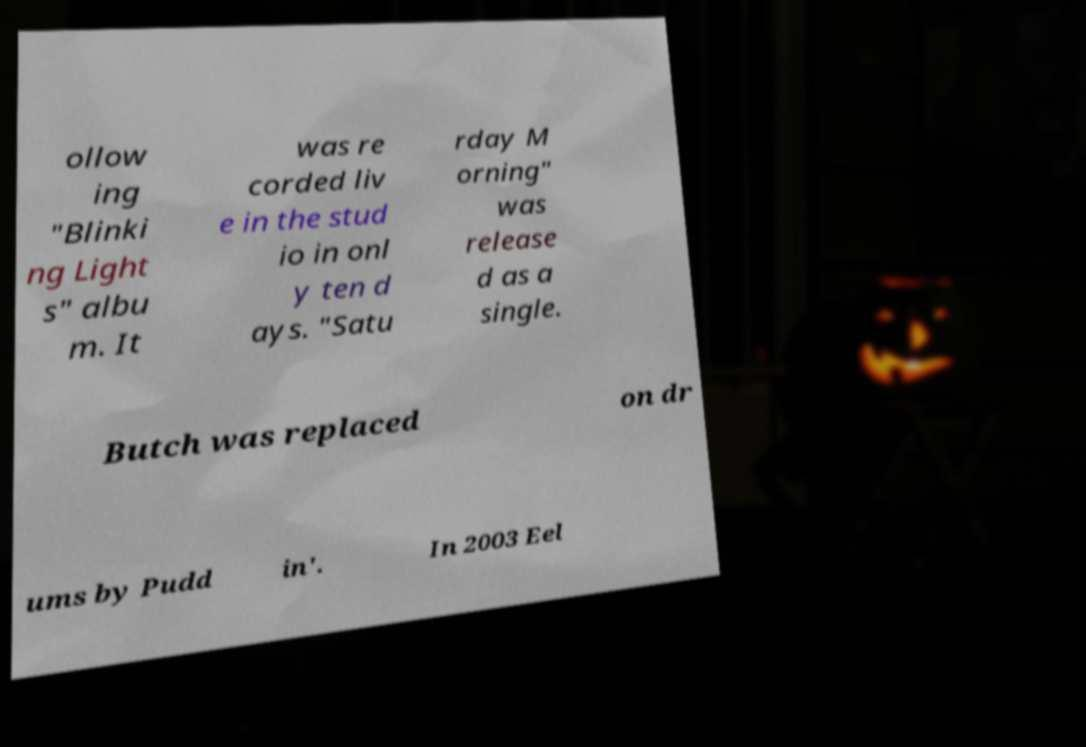Can you accurately transcribe the text from the provided image for me? ollow ing "Blinki ng Light s" albu m. It was re corded liv e in the stud io in onl y ten d ays. "Satu rday M orning" was release d as a single. Butch was replaced on dr ums by Pudd in'. In 2003 Eel 